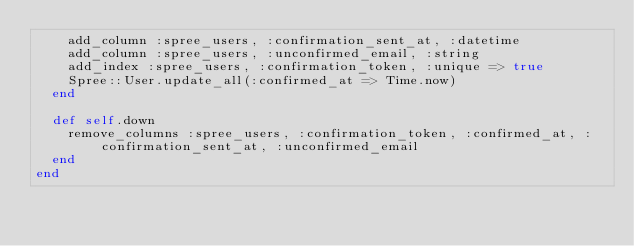Convert code to text. <code><loc_0><loc_0><loc_500><loc_500><_Ruby_>    add_column :spree_users, :confirmation_sent_at, :datetime
    add_column :spree_users, :unconfirmed_email, :string
    add_index :spree_users, :confirmation_token, :unique => true
    Spree::User.update_all(:confirmed_at => Time.now)
  end

  def self.down
    remove_columns :spree_users, :confirmation_token, :confirmed_at, :confirmation_sent_at, :unconfirmed_email
  end
end
</code> 